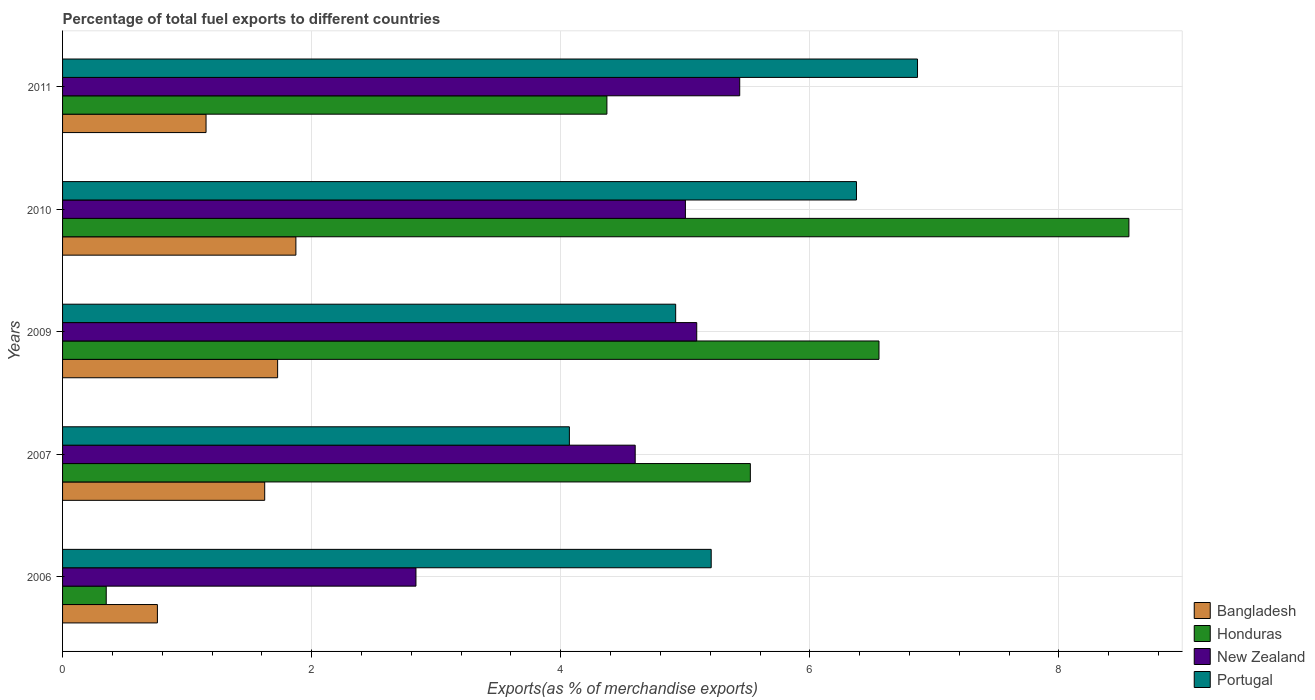How many different coloured bars are there?
Provide a succinct answer. 4. How many groups of bars are there?
Offer a terse response. 5. Are the number of bars per tick equal to the number of legend labels?
Provide a succinct answer. Yes. How many bars are there on the 4th tick from the bottom?
Your answer should be very brief. 4. What is the label of the 3rd group of bars from the top?
Offer a terse response. 2009. What is the percentage of exports to different countries in New Zealand in 2011?
Give a very brief answer. 5.44. Across all years, what is the maximum percentage of exports to different countries in Bangladesh?
Offer a terse response. 1.87. Across all years, what is the minimum percentage of exports to different countries in Portugal?
Provide a short and direct response. 4.07. In which year was the percentage of exports to different countries in Bangladesh maximum?
Offer a very short reply. 2010. What is the total percentage of exports to different countries in Portugal in the graph?
Offer a terse response. 27.44. What is the difference between the percentage of exports to different countries in Bangladesh in 2006 and that in 2007?
Offer a very short reply. -0.86. What is the difference between the percentage of exports to different countries in Portugal in 2010 and the percentage of exports to different countries in Honduras in 2006?
Give a very brief answer. 6.02. What is the average percentage of exports to different countries in Bangladesh per year?
Your answer should be compact. 1.43. In the year 2010, what is the difference between the percentage of exports to different countries in Bangladesh and percentage of exports to different countries in Honduras?
Give a very brief answer. -6.69. What is the ratio of the percentage of exports to different countries in Portugal in 2010 to that in 2011?
Ensure brevity in your answer.  0.93. What is the difference between the highest and the second highest percentage of exports to different countries in Honduras?
Offer a very short reply. 2.01. What is the difference between the highest and the lowest percentage of exports to different countries in New Zealand?
Your response must be concise. 2.6. Is the sum of the percentage of exports to different countries in Bangladesh in 2006 and 2009 greater than the maximum percentage of exports to different countries in New Zealand across all years?
Your answer should be very brief. No. Is it the case that in every year, the sum of the percentage of exports to different countries in New Zealand and percentage of exports to different countries in Portugal is greater than the sum of percentage of exports to different countries in Bangladesh and percentage of exports to different countries in Honduras?
Provide a short and direct response. No. What does the 1st bar from the top in 2010 represents?
Offer a very short reply. Portugal. What does the 1st bar from the bottom in 2010 represents?
Your answer should be compact. Bangladesh. Are all the bars in the graph horizontal?
Your answer should be very brief. Yes. What is the difference between two consecutive major ticks on the X-axis?
Provide a succinct answer. 2. Does the graph contain any zero values?
Offer a terse response. No. Where does the legend appear in the graph?
Ensure brevity in your answer.  Bottom right. How many legend labels are there?
Keep it short and to the point. 4. How are the legend labels stacked?
Provide a succinct answer. Vertical. What is the title of the graph?
Your response must be concise. Percentage of total fuel exports to different countries. Does "Zambia" appear as one of the legend labels in the graph?
Keep it short and to the point. No. What is the label or title of the X-axis?
Ensure brevity in your answer.  Exports(as % of merchandise exports). What is the label or title of the Y-axis?
Provide a succinct answer. Years. What is the Exports(as % of merchandise exports) in Bangladesh in 2006?
Offer a very short reply. 0.76. What is the Exports(as % of merchandise exports) in Honduras in 2006?
Keep it short and to the point. 0.35. What is the Exports(as % of merchandise exports) in New Zealand in 2006?
Ensure brevity in your answer.  2.84. What is the Exports(as % of merchandise exports) in Portugal in 2006?
Ensure brevity in your answer.  5.21. What is the Exports(as % of merchandise exports) in Bangladesh in 2007?
Your answer should be compact. 1.62. What is the Exports(as % of merchandise exports) in Honduras in 2007?
Make the answer very short. 5.52. What is the Exports(as % of merchandise exports) of New Zealand in 2007?
Your response must be concise. 4.6. What is the Exports(as % of merchandise exports) in Portugal in 2007?
Offer a terse response. 4.07. What is the Exports(as % of merchandise exports) of Bangladesh in 2009?
Provide a short and direct response. 1.73. What is the Exports(as % of merchandise exports) of Honduras in 2009?
Ensure brevity in your answer.  6.56. What is the Exports(as % of merchandise exports) of New Zealand in 2009?
Ensure brevity in your answer.  5.09. What is the Exports(as % of merchandise exports) in Portugal in 2009?
Provide a short and direct response. 4.92. What is the Exports(as % of merchandise exports) of Bangladesh in 2010?
Keep it short and to the point. 1.87. What is the Exports(as % of merchandise exports) in Honduras in 2010?
Provide a succinct answer. 8.56. What is the Exports(as % of merchandise exports) of New Zealand in 2010?
Your response must be concise. 5. What is the Exports(as % of merchandise exports) of Portugal in 2010?
Ensure brevity in your answer.  6.37. What is the Exports(as % of merchandise exports) in Bangladesh in 2011?
Offer a very short reply. 1.15. What is the Exports(as % of merchandise exports) in Honduras in 2011?
Give a very brief answer. 4.37. What is the Exports(as % of merchandise exports) in New Zealand in 2011?
Offer a terse response. 5.44. What is the Exports(as % of merchandise exports) of Portugal in 2011?
Your answer should be compact. 6.86. Across all years, what is the maximum Exports(as % of merchandise exports) in Bangladesh?
Keep it short and to the point. 1.87. Across all years, what is the maximum Exports(as % of merchandise exports) of Honduras?
Keep it short and to the point. 8.56. Across all years, what is the maximum Exports(as % of merchandise exports) in New Zealand?
Your answer should be very brief. 5.44. Across all years, what is the maximum Exports(as % of merchandise exports) of Portugal?
Offer a terse response. 6.86. Across all years, what is the minimum Exports(as % of merchandise exports) of Bangladesh?
Provide a succinct answer. 0.76. Across all years, what is the minimum Exports(as % of merchandise exports) in Honduras?
Keep it short and to the point. 0.35. Across all years, what is the minimum Exports(as % of merchandise exports) of New Zealand?
Give a very brief answer. 2.84. Across all years, what is the minimum Exports(as % of merchandise exports) in Portugal?
Your answer should be compact. 4.07. What is the total Exports(as % of merchandise exports) in Bangladesh in the graph?
Your response must be concise. 7.14. What is the total Exports(as % of merchandise exports) of Honduras in the graph?
Provide a short and direct response. 25.36. What is the total Exports(as % of merchandise exports) of New Zealand in the graph?
Your response must be concise. 22.96. What is the total Exports(as % of merchandise exports) of Portugal in the graph?
Give a very brief answer. 27.44. What is the difference between the Exports(as % of merchandise exports) of Bangladesh in 2006 and that in 2007?
Offer a terse response. -0.86. What is the difference between the Exports(as % of merchandise exports) in Honduras in 2006 and that in 2007?
Your answer should be very brief. -5.17. What is the difference between the Exports(as % of merchandise exports) of New Zealand in 2006 and that in 2007?
Give a very brief answer. -1.76. What is the difference between the Exports(as % of merchandise exports) in Portugal in 2006 and that in 2007?
Ensure brevity in your answer.  1.14. What is the difference between the Exports(as % of merchandise exports) in Bangladesh in 2006 and that in 2009?
Provide a succinct answer. -0.97. What is the difference between the Exports(as % of merchandise exports) of Honduras in 2006 and that in 2009?
Keep it short and to the point. -6.2. What is the difference between the Exports(as % of merchandise exports) of New Zealand in 2006 and that in 2009?
Give a very brief answer. -2.25. What is the difference between the Exports(as % of merchandise exports) in Portugal in 2006 and that in 2009?
Ensure brevity in your answer.  0.29. What is the difference between the Exports(as % of merchandise exports) in Bangladesh in 2006 and that in 2010?
Offer a very short reply. -1.11. What is the difference between the Exports(as % of merchandise exports) of Honduras in 2006 and that in 2010?
Keep it short and to the point. -8.21. What is the difference between the Exports(as % of merchandise exports) of New Zealand in 2006 and that in 2010?
Ensure brevity in your answer.  -2.16. What is the difference between the Exports(as % of merchandise exports) in Portugal in 2006 and that in 2010?
Provide a succinct answer. -1.17. What is the difference between the Exports(as % of merchandise exports) of Bangladesh in 2006 and that in 2011?
Provide a short and direct response. -0.39. What is the difference between the Exports(as % of merchandise exports) of Honduras in 2006 and that in 2011?
Give a very brief answer. -4.02. What is the difference between the Exports(as % of merchandise exports) in New Zealand in 2006 and that in 2011?
Keep it short and to the point. -2.6. What is the difference between the Exports(as % of merchandise exports) in Portugal in 2006 and that in 2011?
Make the answer very short. -1.66. What is the difference between the Exports(as % of merchandise exports) of Bangladesh in 2007 and that in 2009?
Offer a very short reply. -0.1. What is the difference between the Exports(as % of merchandise exports) in Honduras in 2007 and that in 2009?
Your response must be concise. -1.03. What is the difference between the Exports(as % of merchandise exports) in New Zealand in 2007 and that in 2009?
Your answer should be very brief. -0.49. What is the difference between the Exports(as % of merchandise exports) of Portugal in 2007 and that in 2009?
Provide a succinct answer. -0.85. What is the difference between the Exports(as % of merchandise exports) of Bangladesh in 2007 and that in 2010?
Give a very brief answer. -0.25. What is the difference between the Exports(as % of merchandise exports) of Honduras in 2007 and that in 2010?
Make the answer very short. -3.04. What is the difference between the Exports(as % of merchandise exports) in New Zealand in 2007 and that in 2010?
Give a very brief answer. -0.4. What is the difference between the Exports(as % of merchandise exports) in Portugal in 2007 and that in 2010?
Make the answer very short. -2.31. What is the difference between the Exports(as % of merchandise exports) in Bangladesh in 2007 and that in 2011?
Ensure brevity in your answer.  0.47. What is the difference between the Exports(as % of merchandise exports) of Honduras in 2007 and that in 2011?
Offer a very short reply. 1.15. What is the difference between the Exports(as % of merchandise exports) in New Zealand in 2007 and that in 2011?
Your answer should be very brief. -0.84. What is the difference between the Exports(as % of merchandise exports) of Portugal in 2007 and that in 2011?
Your answer should be compact. -2.8. What is the difference between the Exports(as % of merchandise exports) of Bangladesh in 2009 and that in 2010?
Offer a terse response. -0.15. What is the difference between the Exports(as % of merchandise exports) in Honduras in 2009 and that in 2010?
Offer a very short reply. -2.01. What is the difference between the Exports(as % of merchandise exports) of New Zealand in 2009 and that in 2010?
Ensure brevity in your answer.  0.09. What is the difference between the Exports(as % of merchandise exports) in Portugal in 2009 and that in 2010?
Keep it short and to the point. -1.45. What is the difference between the Exports(as % of merchandise exports) of Bangladesh in 2009 and that in 2011?
Provide a short and direct response. 0.57. What is the difference between the Exports(as % of merchandise exports) of Honduras in 2009 and that in 2011?
Your answer should be very brief. 2.18. What is the difference between the Exports(as % of merchandise exports) in New Zealand in 2009 and that in 2011?
Provide a succinct answer. -0.35. What is the difference between the Exports(as % of merchandise exports) of Portugal in 2009 and that in 2011?
Give a very brief answer. -1.94. What is the difference between the Exports(as % of merchandise exports) of Bangladesh in 2010 and that in 2011?
Keep it short and to the point. 0.72. What is the difference between the Exports(as % of merchandise exports) in Honduras in 2010 and that in 2011?
Ensure brevity in your answer.  4.19. What is the difference between the Exports(as % of merchandise exports) of New Zealand in 2010 and that in 2011?
Keep it short and to the point. -0.44. What is the difference between the Exports(as % of merchandise exports) of Portugal in 2010 and that in 2011?
Provide a short and direct response. -0.49. What is the difference between the Exports(as % of merchandise exports) of Bangladesh in 2006 and the Exports(as % of merchandise exports) of Honduras in 2007?
Give a very brief answer. -4.76. What is the difference between the Exports(as % of merchandise exports) of Bangladesh in 2006 and the Exports(as % of merchandise exports) of New Zealand in 2007?
Ensure brevity in your answer.  -3.84. What is the difference between the Exports(as % of merchandise exports) in Bangladesh in 2006 and the Exports(as % of merchandise exports) in Portugal in 2007?
Keep it short and to the point. -3.31. What is the difference between the Exports(as % of merchandise exports) in Honduras in 2006 and the Exports(as % of merchandise exports) in New Zealand in 2007?
Give a very brief answer. -4.25. What is the difference between the Exports(as % of merchandise exports) in Honduras in 2006 and the Exports(as % of merchandise exports) in Portugal in 2007?
Provide a short and direct response. -3.72. What is the difference between the Exports(as % of merchandise exports) of New Zealand in 2006 and the Exports(as % of merchandise exports) of Portugal in 2007?
Offer a terse response. -1.23. What is the difference between the Exports(as % of merchandise exports) of Bangladesh in 2006 and the Exports(as % of merchandise exports) of Honduras in 2009?
Your response must be concise. -5.79. What is the difference between the Exports(as % of merchandise exports) of Bangladesh in 2006 and the Exports(as % of merchandise exports) of New Zealand in 2009?
Give a very brief answer. -4.33. What is the difference between the Exports(as % of merchandise exports) of Bangladesh in 2006 and the Exports(as % of merchandise exports) of Portugal in 2009?
Your answer should be very brief. -4.16. What is the difference between the Exports(as % of merchandise exports) of Honduras in 2006 and the Exports(as % of merchandise exports) of New Zealand in 2009?
Keep it short and to the point. -4.74. What is the difference between the Exports(as % of merchandise exports) in Honduras in 2006 and the Exports(as % of merchandise exports) in Portugal in 2009?
Keep it short and to the point. -4.57. What is the difference between the Exports(as % of merchandise exports) in New Zealand in 2006 and the Exports(as % of merchandise exports) in Portugal in 2009?
Keep it short and to the point. -2.09. What is the difference between the Exports(as % of merchandise exports) in Bangladesh in 2006 and the Exports(as % of merchandise exports) in Honduras in 2010?
Provide a short and direct response. -7.8. What is the difference between the Exports(as % of merchandise exports) in Bangladesh in 2006 and the Exports(as % of merchandise exports) in New Zealand in 2010?
Your answer should be very brief. -4.24. What is the difference between the Exports(as % of merchandise exports) of Bangladesh in 2006 and the Exports(as % of merchandise exports) of Portugal in 2010?
Your answer should be compact. -5.61. What is the difference between the Exports(as % of merchandise exports) in Honduras in 2006 and the Exports(as % of merchandise exports) in New Zealand in 2010?
Give a very brief answer. -4.65. What is the difference between the Exports(as % of merchandise exports) of Honduras in 2006 and the Exports(as % of merchandise exports) of Portugal in 2010?
Offer a terse response. -6.02. What is the difference between the Exports(as % of merchandise exports) of New Zealand in 2006 and the Exports(as % of merchandise exports) of Portugal in 2010?
Provide a succinct answer. -3.54. What is the difference between the Exports(as % of merchandise exports) in Bangladesh in 2006 and the Exports(as % of merchandise exports) in Honduras in 2011?
Your answer should be very brief. -3.61. What is the difference between the Exports(as % of merchandise exports) of Bangladesh in 2006 and the Exports(as % of merchandise exports) of New Zealand in 2011?
Ensure brevity in your answer.  -4.68. What is the difference between the Exports(as % of merchandise exports) in Bangladesh in 2006 and the Exports(as % of merchandise exports) in Portugal in 2011?
Your answer should be very brief. -6.1. What is the difference between the Exports(as % of merchandise exports) of Honduras in 2006 and the Exports(as % of merchandise exports) of New Zealand in 2011?
Provide a succinct answer. -5.09. What is the difference between the Exports(as % of merchandise exports) in Honduras in 2006 and the Exports(as % of merchandise exports) in Portugal in 2011?
Your response must be concise. -6.51. What is the difference between the Exports(as % of merchandise exports) of New Zealand in 2006 and the Exports(as % of merchandise exports) of Portugal in 2011?
Keep it short and to the point. -4.03. What is the difference between the Exports(as % of merchandise exports) in Bangladesh in 2007 and the Exports(as % of merchandise exports) in Honduras in 2009?
Make the answer very short. -4.93. What is the difference between the Exports(as % of merchandise exports) in Bangladesh in 2007 and the Exports(as % of merchandise exports) in New Zealand in 2009?
Ensure brevity in your answer.  -3.47. What is the difference between the Exports(as % of merchandise exports) of Bangladesh in 2007 and the Exports(as % of merchandise exports) of Portugal in 2009?
Provide a succinct answer. -3.3. What is the difference between the Exports(as % of merchandise exports) of Honduras in 2007 and the Exports(as % of merchandise exports) of New Zealand in 2009?
Provide a succinct answer. 0.43. What is the difference between the Exports(as % of merchandise exports) of Honduras in 2007 and the Exports(as % of merchandise exports) of Portugal in 2009?
Provide a succinct answer. 0.6. What is the difference between the Exports(as % of merchandise exports) of New Zealand in 2007 and the Exports(as % of merchandise exports) of Portugal in 2009?
Offer a terse response. -0.33. What is the difference between the Exports(as % of merchandise exports) of Bangladesh in 2007 and the Exports(as % of merchandise exports) of Honduras in 2010?
Keep it short and to the point. -6.94. What is the difference between the Exports(as % of merchandise exports) of Bangladesh in 2007 and the Exports(as % of merchandise exports) of New Zealand in 2010?
Your answer should be very brief. -3.38. What is the difference between the Exports(as % of merchandise exports) of Bangladesh in 2007 and the Exports(as % of merchandise exports) of Portugal in 2010?
Your answer should be compact. -4.75. What is the difference between the Exports(as % of merchandise exports) of Honduras in 2007 and the Exports(as % of merchandise exports) of New Zealand in 2010?
Ensure brevity in your answer.  0.52. What is the difference between the Exports(as % of merchandise exports) of Honduras in 2007 and the Exports(as % of merchandise exports) of Portugal in 2010?
Make the answer very short. -0.85. What is the difference between the Exports(as % of merchandise exports) of New Zealand in 2007 and the Exports(as % of merchandise exports) of Portugal in 2010?
Keep it short and to the point. -1.78. What is the difference between the Exports(as % of merchandise exports) in Bangladesh in 2007 and the Exports(as % of merchandise exports) in Honduras in 2011?
Ensure brevity in your answer.  -2.75. What is the difference between the Exports(as % of merchandise exports) in Bangladesh in 2007 and the Exports(as % of merchandise exports) in New Zealand in 2011?
Offer a terse response. -3.81. What is the difference between the Exports(as % of merchandise exports) in Bangladesh in 2007 and the Exports(as % of merchandise exports) in Portugal in 2011?
Ensure brevity in your answer.  -5.24. What is the difference between the Exports(as % of merchandise exports) in Honduras in 2007 and the Exports(as % of merchandise exports) in New Zealand in 2011?
Ensure brevity in your answer.  0.09. What is the difference between the Exports(as % of merchandise exports) in Honduras in 2007 and the Exports(as % of merchandise exports) in Portugal in 2011?
Offer a terse response. -1.34. What is the difference between the Exports(as % of merchandise exports) of New Zealand in 2007 and the Exports(as % of merchandise exports) of Portugal in 2011?
Offer a very short reply. -2.27. What is the difference between the Exports(as % of merchandise exports) of Bangladesh in 2009 and the Exports(as % of merchandise exports) of Honduras in 2010?
Provide a succinct answer. -6.84. What is the difference between the Exports(as % of merchandise exports) in Bangladesh in 2009 and the Exports(as % of merchandise exports) in New Zealand in 2010?
Your response must be concise. -3.27. What is the difference between the Exports(as % of merchandise exports) in Bangladesh in 2009 and the Exports(as % of merchandise exports) in Portugal in 2010?
Give a very brief answer. -4.65. What is the difference between the Exports(as % of merchandise exports) of Honduras in 2009 and the Exports(as % of merchandise exports) of New Zealand in 2010?
Provide a short and direct response. 1.55. What is the difference between the Exports(as % of merchandise exports) of Honduras in 2009 and the Exports(as % of merchandise exports) of Portugal in 2010?
Offer a terse response. 0.18. What is the difference between the Exports(as % of merchandise exports) of New Zealand in 2009 and the Exports(as % of merchandise exports) of Portugal in 2010?
Provide a short and direct response. -1.28. What is the difference between the Exports(as % of merchandise exports) of Bangladesh in 2009 and the Exports(as % of merchandise exports) of Honduras in 2011?
Ensure brevity in your answer.  -2.64. What is the difference between the Exports(as % of merchandise exports) of Bangladesh in 2009 and the Exports(as % of merchandise exports) of New Zealand in 2011?
Make the answer very short. -3.71. What is the difference between the Exports(as % of merchandise exports) of Bangladesh in 2009 and the Exports(as % of merchandise exports) of Portugal in 2011?
Your answer should be compact. -5.14. What is the difference between the Exports(as % of merchandise exports) in Honduras in 2009 and the Exports(as % of merchandise exports) in New Zealand in 2011?
Keep it short and to the point. 1.12. What is the difference between the Exports(as % of merchandise exports) in Honduras in 2009 and the Exports(as % of merchandise exports) in Portugal in 2011?
Offer a terse response. -0.31. What is the difference between the Exports(as % of merchandise exports) of New Zealand in 2009 and the Exports(as % of merchandise exports) of Portugal in 2011?
Provide a succinct answer. -1.77. What is the difference between the Exports(as % of merchandise exports) in Bangladesh in 2010 and the Exports(as % of merchandise exports) in Honduras in 2011?
Your response must be concise. -2.5. What is the difference between the Exports(as % of merchandise exports) of Bangladesh in 2010 and the Exports(as % of merchandise exports) of New Zealand in 2011?
Give a very brief answer. -3.56. What is the difference between the Exports(as % of merchandise exports) in Bangladesh in 2010 and the Exports(as % of merchandise exports) in Portugal in 2011?
Offer a terse response. -4.99. What is the difference between the Exports(as % of merchandise exports) in Honduras in 2010 and the Exports(as % of merchandise exports) in New Zealand in 2011?
Your response must be concise. 3.12. What is the difference between the Exports(as % of merchandise exports) of Honduras in 2010 and the Exports(as % of merchandise exports) of Portugal in 2011?
Provide a succinct answer. 1.7. What is the difference between the Exports(as % of merchandise exports) of New Zealand in 2010 and the Exports(as % of merchandise exports) of Portugal in 2011?
Offer a terse response. -1.86. What is the average Exports(as % of merchandise exports) of Bangladesh per year?
Give a very brief answer. 1.43. What is the average Exports(as % of merchandise exports) in Honduras per year?
Make the answer very short. 5.07. What is the average Exports(as % of merchandise exports) of New Zealand per year?
Keep it short and to the point. 4.59. What is the average Exports(as % of merchandise exports) in Portugal per year?
Your answer should be compact. 5.49. In the year 2006, what is the difference between the Exports(as % of merchandise exports) of Bangladesh and Exports(as % of merchandise exports) of Honduras?
Provide a short and direct response. 0.41. In the year 2006, what is the difference between the Exports(as % of merchandise exports) of Bangladesh and Exports(as % of merchandise exports) of New Zealand?
Keep it short and to the point. -2.08. In the year 2006, what is the difference between the Exports(as % of merchandise exports) of Bangladesh and Exports(as % of merchandise exports) of Portugal?
Offer a terse response. -4.45. In the year 2006, what is the difference between the Exports(as % of merchandise exports) of Honduras and Exports(as % of merchandise exports) of New Zealand?
Offer a terse response. -2.49. In the year 2006, what is the difference between the Exports(as % of merchandise exports) in Honduras and Exports(as % of merchandise exports) in Portugal?
Your response must be concise. -4.86. In the year 2006, what is the difference between the Exports(as % of merchandise exports) of New Zealand and Exports(as % of merchandise exports) of Portugal?
Make the answer very short. -2.37. In the year 2007, what is the difference between the Exports(as % of merchandise exports) in Bangladesh and Exports(as % of merchandise exports) in Honduras?
Your answer should be compact. -3.9. In the year 2007, what is the difference between the Exports(as % of merchandise exports) of Bangladesh and Exports(as % of merchandise exports) of New Zealand?
Provide a short and direct response. -2.97. In the year 2007, what is the difference between the Exports(as % of merchandise exports) of Bangladesh and Exports(as % of merchandise exports) of Portugal?
Provide a succinct answer. -2.45. In the year 2007, what is the difference between the Exports(as % of merchandise exports) of Honduras and Exports(as % of merchandise exports) of New Zealand?
Give a very brief answer. 0.92. In the year 2007, what is the difference between the Exports(as % of merchandise exports) in Honduras and Exports(as % of merchandise exports) in Portugal?
Keep it short and to the point. 1.45. In the year 2007, what is the difference between the Exports(as % of merchandise exports) in New Zealand and Exports(as % of merchandise exports) in Portugal?
Keep it short and to the point. 0.53. In the year 2009, what is the difference between the Exports(as % of merchandise exports) in Bangladesh and Exports(as % of merchandise exports) in Honduras?
Provide a succinct answer. -4.83. In the year 2009, what is the difference between the Exports(as % of merchandise exports) in Bangladesh and Exports(as % of merchandise exports) in New Zealand?
Your answer should be compact. -3.37. In the year 2009, what is the difference between the Exports(as % of merchandise exports) in Bangladesh and Exports(as % of merchandise exports) in Portugal?
Offer a terse response. -3.2. In the year 2009, what is the difference between the Exports(as % of merchandise exports) of Honduras and Exports(as % of merchandise exports) of New Zealand?
Your answer should be very brief. 1.46. In the year 2009, what is the difference between the Exports(as % of merchandise exports) in Honduras and Exports(as % of merchandise exports) in Portugal?
Provide a succinct answer. 1.63. In the year 2009, what is the difference between the Exports(as % of merchandise exports) in New Zealand and Exports(as % of merchandise exports) in Portugal?
Ensure brevity in your answer.  0.17. In the year 2010, what is the difference between the Exports(as % of merchandise exports) of Bangladesh and Exports(as % of merchandise exports) of Honduras?
Provide a short and direct response. -6.69. In the year 2010, what is the difference between the Exports(as % of merchandise exports) in Bangladesh and Exports(as % of merchandise exports) in New Zealand?
Offer a very short reply. -3.13. In the year 2010, what is the difference between the Exports(as % of merchandise exports) of Bangladesh and Exports(as % of merchandise exports) of Portugal?
Your response must be concise. -4.5. In the year 2010, what is the difference between the Exports(as % of merchandise exports) in Honduras and Exports(as % of merchandise exports) in New Zealand?
Provide a succinct answer. 3.56. In the year 2010, what is the difference between the Exports(as % of merchandise exports) in Honduras and Exports(as % of merchandise exports) in Portugal?
Keep it short and to the point. 2.19. In the year 2010, what is the difference between the Exports(as % of merchandise exports) of New Zealand and Exports(as % of merchandise exports) of Portugal?
Provide a succinct answer. -1.37. In the year 2011, what is the difference between the Exports(as % of merchandise exports) in Bangladesh and Exports(as % of merchandise exports) in Honduras?
Your answer should be compact. -3.22. In the year 2011, what is the difference between the Exports(as % of merchandise exports) in Bangladesh and Exports(as % of merchandise exports) in New Zealand?
Ensure brevity in your answer.  -4.29. In the year 2011, what is the difference between the Exports(as % of merchandise exports) of Bangladesh and Exports(as % of merchandise exports) of Portugal?
Make the answer very short. -5.71. In the year 2011, what is the difference between the Exports(as % of merchandise exports) of Honduras and Exports(as % of merchandise exports) of New Zealand?
Your answer should be compact. -1.07. In the year 2011, what is the difference between the Exports(as % of merchandise exports) in Honduras and Exports(as % of merchandise exports) in Portugal?
Your answer should be very brief. -2.49. In the year 2011, what is the difference between the Exports(as % of merchandise exports) of New Zealand and Exports(as % of merchandise exports) of Portugal?
Ensure brevity in your answer.  -1.43. What is the ratio of the Exports(as % of merchandise exports) in Bangladesh in 2006 to that in 2007?
Your response must be concise. 0.47. What is the ratio of the Exports(as % of merchandise exports) of Honduras in 2006 to that in 2007?
Your answer should be very brief. 0.06. What is the ratio of the Exports(as % of merchandise exports) in New Zealand in 2006 to that in 2007?
Make the answer very short. 0.62. What is the ratio of the Exports(as % of merchandise exports) in Portugal in 2006 to that in 2007?
Your answer should be compact. 1.28. What is the ratio of the Exports(as % of merchandise exports) of Bangladesh in 2006 to that in 2009?
Keep it short and to the point. 0.44. What is the ratio of the Exports(as % of merchandise exports) of Honduras in 2006 to that in 2009?
Make the answer very short. 0.05. What is the ratio of the Exports(as % of merchandise exports) of New Zealand in 2006 to that in 2009?
Offer a very short reply. 0.56. What is the ratio of the Exports(as % of merchandise exports) in Portugal in 2006 to that in 2009?
Provide a short and direct response. 1.06. What is the ratio of the Exports(as % of merchandise exports) of Bangladesh in 2006 to that in 2010?
Provide a short and direct response. 0.41. What is the ratio of the Exports(as % of merchandise exports) in Honduras in 2006 to that in 2010?
Give a very brief answer. 0.04. What is the ratio of the Exports(as % of merchandise exports) of New Zealand in 2006 to that in 2010?
Offer a very short reply. 0.57. What is the ratio of the Exports(as % of merchandise exports) in Portugal in 2006 to that in 2010?
Your answer should be very brief. 0.82. What is the ratio of the Exports(as % of merchandise exports) in Bangladesh in 2006 to that in 2011?
Make the answer very short. 0.66. What is the ratio of the Exports(as % of merchandise exports) of Honduras in 2006 to that in 2011?
Make the answer very short. 0.08. What is the ratio of the Exports(as % of merchandise exports) in New Zealand in 2006 to that in 2011?
Offer a very short reply. 0.52. What is the ratio of the Exports(as % of merchandise exports) in Portugal in 2006 to that in 2011?
Your answer should be very brief. 0.76. What is the ratio of the Exports(as % of merchandise exports) in Bangladesh in 2007 to that in 2009?
Offer a terse response. 0.94. What is the ratio of the Exports(as % of merchandise exports) in Honduras in 2007 to that in 2009?
Offer a terse response. 0.84. What is the ratio of the Exports(as % of merchandise exports) of New Zealand in 2007 to that in 2009?
Your answer should be very brief. 0.9. What is the ratio of the Exports(as % of merchandise exports) in Portugal in 2007 to that in 2009?
Your answer should be compact. 0.83. What is the ratio of the Exports(as % of merchandise exports) in Bangladesh in 2007 to that in 2010?
Keep it short and to the point. 0.87. What is the ratio of the Exports(as % of merchandise exports) of Honduras in 2007 to that in 2010?
Provide a succinct answer. 0.65. What is the ratio of the Exports(as % of merchandise exports) of New Zealand in 2007 to that in 2010?
Ensure brevity in your answer.  0.92. What is the ratio of the Exports(as % of merchandise exports) in Portugal in 2007 to that in 2010?
Ensure brevity in your answer.  0.64. What is the ratio of the Exports(as % of merchandise exports) of Bangladesh in 2007 to that in 2011?
Your answer should be very brief. 1.41. What is the ratio of the Exports(as % of merchandise exports) of Honduras in 2007 to that in 2011?
Your response must be concise. 1.26. What is the ratio of the Exports(as % of merchandise exports) in New Zealand in 2007 to that in 2011?
Your response must be concise. 0.85. What is the ratio of the Exports(as % of merchandise exports) in Portugal in 2007 to that in 2011?
Offer a very short reply. 0.59. What is the ratio of the Exports(as % of merchandise exports) of Bangladesh in 2009 to that in 2010?
Give a very brief answer. 0.92. What is the ratio of the Exports(as % of merchandise exports) of Honduras in 2009 to that in 2010?
Offer a very short reply. 0.77. What is the ratio of the Exports(as % of merchandise exports) in New Zealand in 2009 to that in 2010?
Your answer should be compact. 1.02. What is the ratio of the Exports(as % of merchandise exports) in Portugal in 2009 to that in 2010?
Offer a very short reply. 0.77. What is the ratio of the Exports(as % of merchandise exports) of Bangladesh in 2009 to that in 2011?
Provide a short and direct response. 1.5. What is the ratio of the Exports(as % of merchandise exports) of Honduras in 2009 to that in 2011?
Provide a succinct answer. 1.5. What is the ratio of the Exports(as % of merchandise exports) of New Zealand in 2009 to that in 2011?
Provide a succinct answer. 0.94. What is the ratio of the Exports(as % of merchandise exports) in Portugal in 2009 to that in 2011?
Give a very brief answer. 0.72. What is the ratio of the Exports(as % of merchandise exports) of Bangladesh in 2010 to that in 2011?
Your answer should be compact. 1.63. What is the ratio of the Exports(as % of merchandise exports) of Honduras in 2010 to that in 2011?
Give a very brief answer. 1.96. What is the ratio of the Exports(as % of merchandise exports) in New Zealand in 2010 to that in 2011?
Ensure brevity in your answer.  0.92. What is the ratio of the Exports(as % of merchandise exports) in Portugal in 2010 to that in 2011?
Offer a terse response. 0.93. What is the difference between the highest and the second highest Exports(as % of merchandise exports) in Bangladesh?
Provide a short and direct response. 0.15. What is the difference between the highest and the second highest Exports(as % of merchandise exports) in Honduras?
Your answer should be compact. 2.01. What is the difference between the highest and the second highest Exports(as % of merchandise exports) in New Zealand?
Provide a short and direct response. 0.35. What is the difference between the highest and the second highest Exports(as % of merchandise exports) in Portugal?
Provide a succinct answer. 0.49. What is the difference between the highest and the lowest Exports(as % of merchandise exports) of Bangladesh?
Your response must be concise. 1.11. What is the difference between the highest and the lowest Exports(as % of merchandise exports) of Honduras?
Offer a terse response. 8.21. What is the difference between the highest and the lowest Exports(as % of merchandise exports) of New Zealand?
Offer a very short reply. 2.6. What is the difference between the highest and the lowest Exports(as % of merchandise exports) in Portugal?
Make the answer very short. 2.8. 